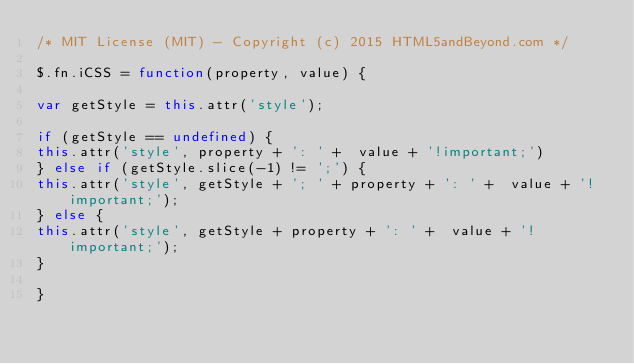<code> <loc_0><loc_0><loc_500><loc_500><_JavaScript_>/* MIT License (MIT) - Copyright (c) 2015 HTML5andBeyond.com */

$.fn.iCSS = function(property, value) {

var getStyle = this.attr('style');

if (getStyle == undefined) {
this.attr('style', property + ': ' +  value + '!important;')
} else if (getStyle.slice(-1) != ';') {
this.attr('style', getStyle + '; ' + property + ': ' +  value + '!important;');
} else {
this.attr('style', getStyle + property + ': ' +  value + '!important;');
}

}</code> 